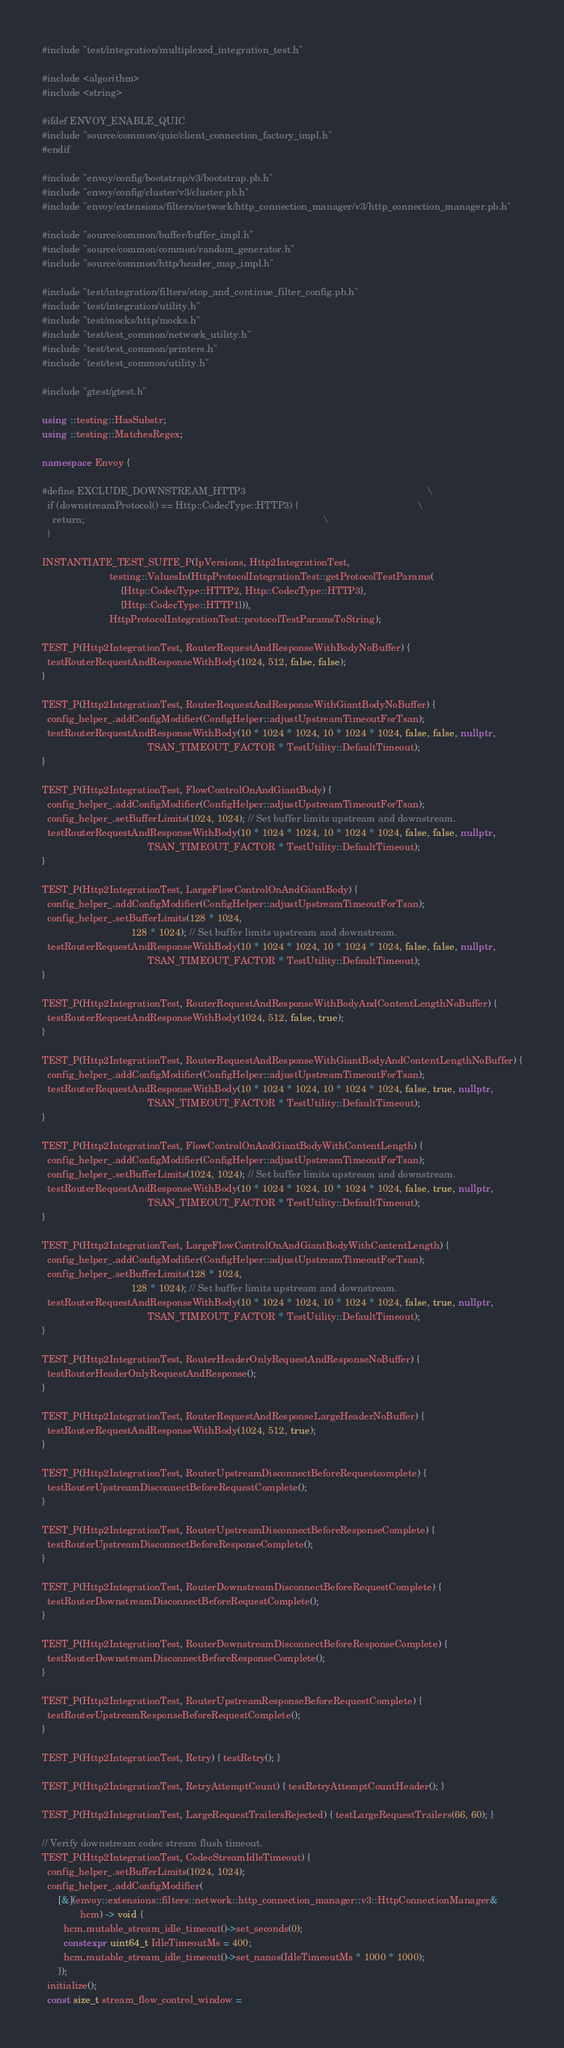Convert code to text. <code><loc_0><loc_0><loc_500><loc_500><_C++_>#include "test/integration/multiplexed_integration_test.h"

#include <algorithm>
#include <string>

#ifdef ENVOY_ENABLE_QUIC
#include "source/common/quic/client_connection_factory_impl.h"
#endif

#include "envoy/config/bootstrap/v3/bootstrap.pb.h"
#include "envoy/config/cluster/v3/cluster.pb.h"
#include "envoy/extensions/filters/network/http_connection_manager/v3/http_connection_manager.pb.h"

#include "source/common/buffer/buffer_impl.h"
#include "source/common/common/random_generator.h"
#include "source/common/http/header_map_impl.h"

#include "test/integration/filters/stop_and_continue_filter_config.pb.h"
#include "test/integration/utility.h"
#include "test/mocks/http/mocks.h"
#include "test/test_common/network_utility.h"
#include "test/test_common/printers.h"
#include "test/test_common/utility.h"

#include "gtest/gtest.h"

using ::testing::HasSubstr;
using ::testing::MatchesRegex;

namespace Envoy {

#define EXCLUDE_DOWNSTREAM_HTTP3                                                                   \
  if (downstreamProtocol() == Http::CodecType::HTTP3) {                                            \
    return;                                                                                        \
  }

INSTANTIATE_TEST_SUITE_P(IpVersions, Http2IntegrationTest,
                         testing::ValuesIn(HttpProtocolIntegrationTest::getProtocolTestParams(
                             {Http::CodecType::HTTP2, Http::CodecType::HTTP3},
                             {Http::CodecType::HTTP1})),
                         HttpProtocolIntegrationTest::protocolTestParamsToString);

TEST_P(Http2IntegrationTest, RouterRequestAndResponseWithBodyNoBuffer) {
  testRouterRequestAndResponseWithBody(1024, 512, false, false);
}

TEST_P(Http2IntegrationTest, RouterRequestAndResponseWithGiantBodyNoBuffer) {
  config_helper_.addConfigModifier(ConfigHelper::adjustUpstreamTimeoutForTsan);
  testRouterRequestAndResponseWithBody(10 * 1024 * 1024, 10 * 1024 * 1024, false, false, nullptr,
                                       TSAN_TIMEOUT_FACTOR * TestUtility::DefaultTimeout);
}

TEST_P(Http2IntegrationTest, FlowControlOnAndGiantBody) {
  config_helper_.addConfigModifier(ConfigHelper::adjustUpstreamTimeoutForTsan);
  config_helper_.setBufferLimits(1024, 1024); // Set buffer limits upstream and downstream.
  testRouterRequestAndResponseWithBody(10 * 1024 * 1024, 10 * 1024 * 1024, false, false, nullptr,
                                       TSAN_TIMEOUT_FACTOR * TestUtility::DefaultTimeout);
}

TEST_P(Http2IntegrationTest, LargeFlowControlOnAndGiantBody) {
  config_helper_.addConfigModifier(ConfigHelper::adjustUpstreamTimeoutForTsan);
  config_helper_.setBufferLimits(128 * 1024,
                                 128 * 1024); // Set buffer limits upstream and downstream.
  testRouterRequestAndResponseWithBody(10 * 1024 * 1024, 10 * 1024 * 1024, false, false, nullptr,
                                       TSAN_TIMEOUT_FACTOR * TestUtility::DefaultTimeout);
}

TEST_P(Http2IntegrationTest, RouterRequestAndResponseWithBodyAndContentLengthNoBuffer) {
  testRouterRequestAndResponseWithBody(1024, 512, false, true);
}

TEST_P(Http2IntegrationTest, RouterRequestAndResponseWithGiantBodyAndContentLengthNoBuffer) {
  config_helper_.addConfigModifier(ConfigHelper::adjustUpstreamTimeoutForTsan);
  testRouterRequestAndResponseWithBody(10 * 1024 * 1024, 10 * 1024 * 1024, false, true, nullptr,
                                       TSAN_TIMEOUT_FACTOR * TestUtility::DefaultTimeout);
}

TEST_P(Http2IntegrationTest, FlowControlOnAndGiantBodyWithContentLength) {
  config_helper_.addConfigModifier(ConfigHelper::adjustUpstreamTimeoutForTsan);
  config_helper_.setBufferLimits(1024, 1024); // Set buffer limits upstream and downstream.
  testRouterRequestAndResponseWithBody(10 * 1024 * 1024, 10 * 1024 * 1024, false, true, nullptr,
                                       TSAN_TIMEOUT_FACTOR * TestUtility::DefaultTimeout);
}

TEST_P(Http2IntegrationTest, LargeFlowControlOnAndGiantBodyWithContentLength) {
  config_helper_.addConfigModifier(ConfigHelper::adjustUpstreamTimeoutForTsan);
  config_helper_.setBufferLimits(128 * 1024,
                                 128 * 1024); // Set buffer limits upstream and downstream.
  testRouterRequestAndResponseWithBody(10 * 1024 * 1024, 10 * 1024 * 1024, false, true, nullptr,
                                       TSAN_TIMEOUT_FACTOR * TestUtility::DefaultTimeout);
}

TEST_P(Http2IntegrationTest, RouterHeaderOnlyRequestAndResponseNoBuffer) {
  testRouterHeaderOnlyRequestAndResponse();
}

TEST_P(Http2IntegrationTest, RouterRequestAndResponseLargeHeaderNoBuffer) {
  testRouterRequestAndResponseWithBody(1024, 512, true);
}

TEST_P(Http2IntegrationTest, RouterUpstreamDisconnectBeforeRequestcomplete) {
  testRouterUpstreamDisconnectBeforeRequestComplete();
}

TEST_P(Http2IntegrationTest, RouterUpstreamDisconnectBeforeResponseComplete) {
  testRouterUpstreamDisconnectBeforeResponseComplete();
}

TEST_P(Http2IntegrationTest, RouterDownstreamDisconnectBeforeRequestComplete) {
  testRouterDownstreamDisconnectBeforeRequestComplete();
}

TEST_P(Http2IntegrationTest, RouterDownstreamDisconnectBeforeResponseComplete) {
  testRouterDownstreamDisconnectBeforeResponseComplete();
}

TEST_P(Http2IntegrationTest, RouterUpstreamResponseBeforeRequestComplete) {
  testRouterUpstreamResponseBeforeRequestComplete();
}

TEST_P(Http2IntegrationTest, Retry) { testRetry(); }

TEST_P(Http2IntegrationTest, RetryAttemptCount) { testRetryAttemptCountHeader(); }

TEST_P(Http2IntegrationTest, LargeRequestTrailersRejected) { testLargeRequestTrailers(66, 60); }

// Verify downstream codec stream flush timeout.
TEST_P(Http2IntegrationTest, CodecStreamIdleTimeout) {
  config_helper_.setBufferLimits(1024, 1024);
  config_helper_.addConfigModifier(
      [&](envoy::extensions::filters::network::http_connection_manager::v3::HttpConnectionManager&
              hcm) -> void {
        hcm.mutable_stream_idle_timeout()->set_seconds(0);
        constexpr uint64_t IdleTimeoutMs = 400;
        hcm.mutable_stream_idle_timeout()->set_nanos(IdleTimeoutMs * 1000 * 1000);
      });
  initialize();
  const size_t stream_flow_control_window =</code> 